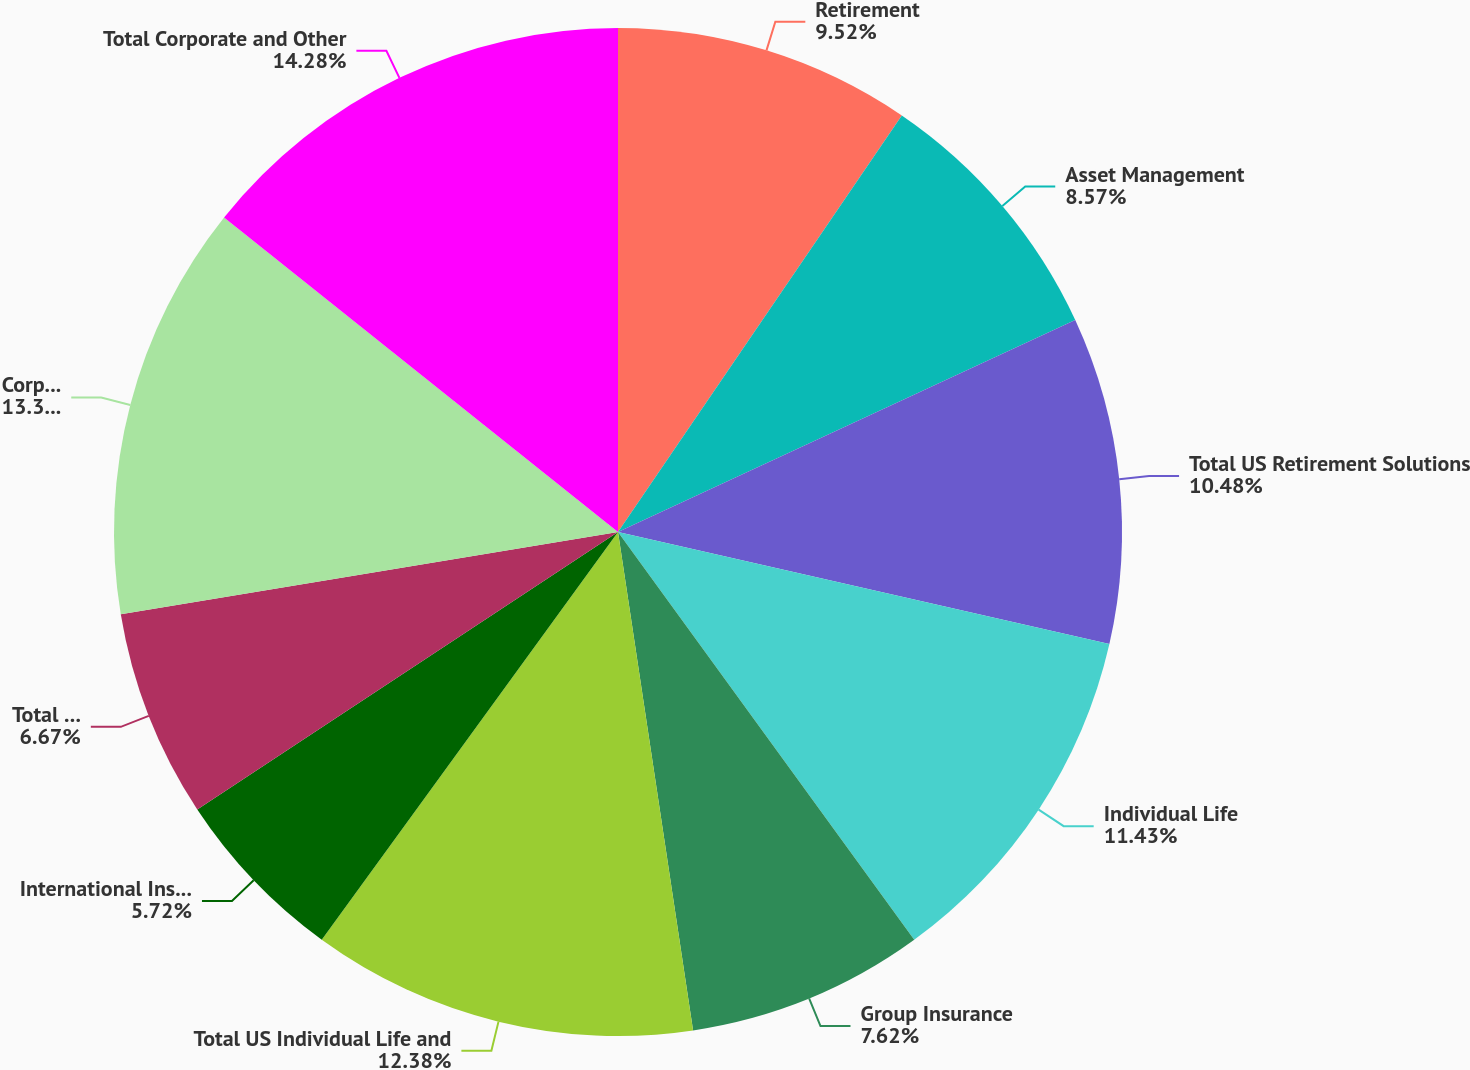<chart> <loc_0><loc_0><loc_500><loc_500><pie_chart><fcel>Retirement<fcel>Asset Management<fcel>Total US Retirement Solutions<fcel>Individual Life<fcel>Group Insurance<fcel>Total US Individual Life and<fcel>International Insurance<fcel>Total International Insurance<fcel>Corporate and Other operations<fcel>Total Corporate and Other<nl><fcel>9.52%<fcel>8.57%<fcel>10.48%<fcel>11.43%<fcel>7.62%<fcel>12.38%<fcel>5.72%<fcel>6.67%<fcel>13.33%<fcel>14.28%<nl></chart> 